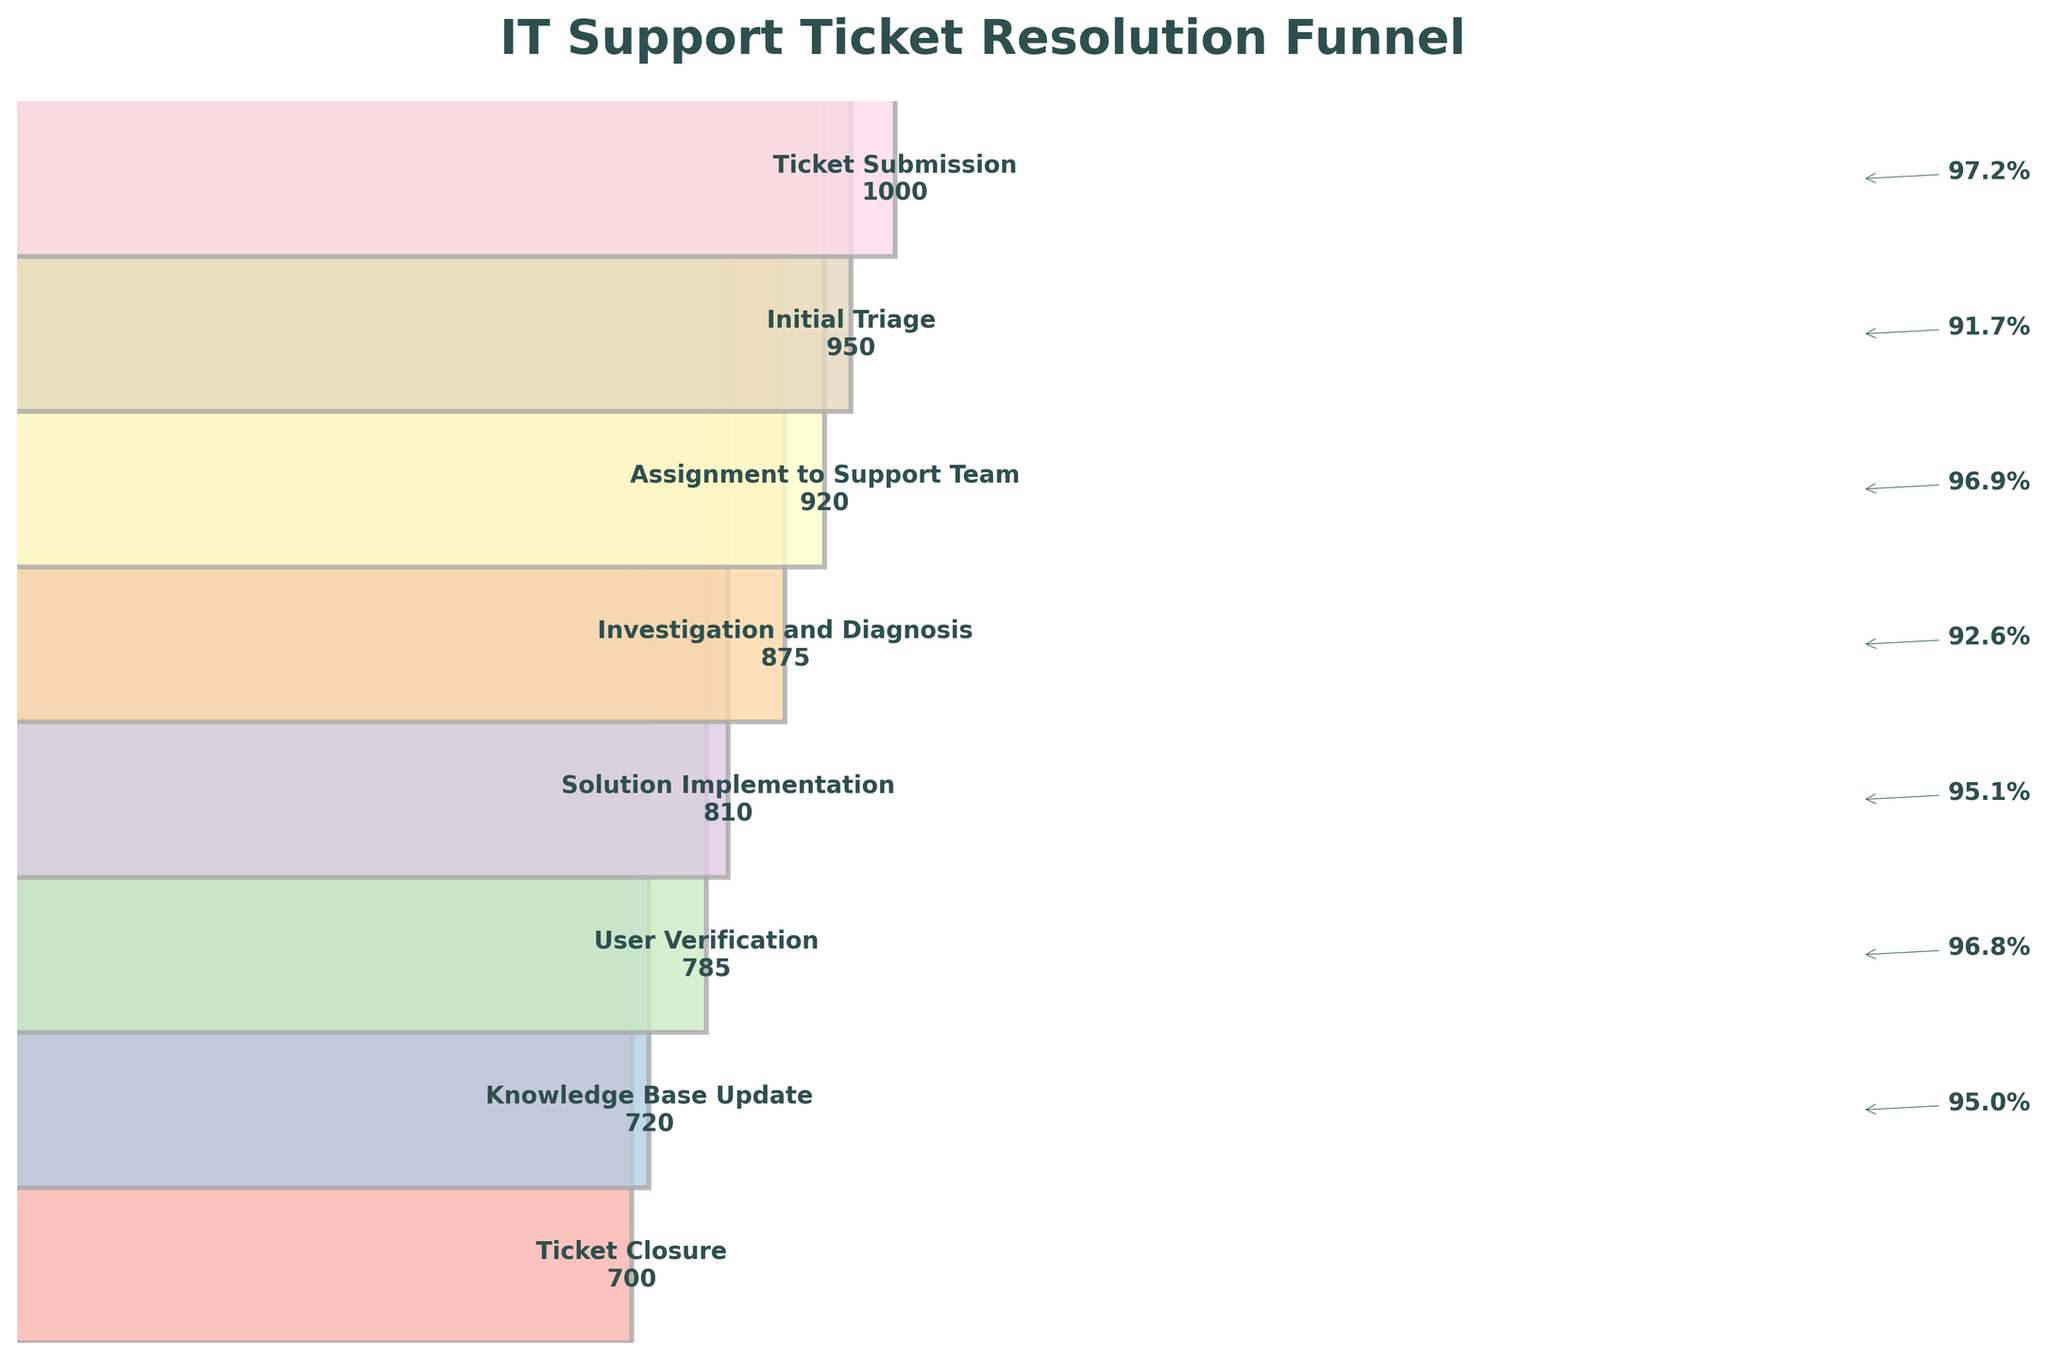What's the title of the figure? The title is located at the top of the figure in bold and large font to give a clear summary of what the chart represents. The title reads "IT Support Ticket Resolution Funnel".
Answer: IT Support Ticket Resolution Funnel How many support tickets make it to the 'Investigation and Diagnosis' step? The number of tickets at each step is labeled on the corresponding bars in the funnel chart. The 'Investigation and Diagnosis' step has 875 tickets.
Answer: 875 Which step shows the largest drop in the number of tickets from the previous step? By observing the percentage annotations between each step, you can determine the largest drop. The largest drop is from 'Solution Implementation' to 'User Verification', where it drops from 810 to 785.
Answer: Solution Implementation to User Verification What is the percentage of tickets that go from 'Ticket Submission' to 'Initial Triage'? The funnel chart shows numeric tickets at each step. The percentage can be calculated as (950 / 1000) * 100 which gives 95%.
Answer: 95% Compare the number of tickets at 'Assignment to Support Team' and 'Ticket Closure'. How many tickets are there in each step, and how many tickets were closed successfully? From the chart, 'Assignment to Support Team' has 920 tickets, and 'Ticket Closure' has 700 tickets. Therefore, 700 tickets are successfully closed.
Answer: Assignment to Support Team: 920, Ticket Closure: 700, 700 tickets closed successfully What is the difference in the number of tickets between 'Initial Triage' and 'Knowledge Base Update'? By looking at both steps, 'Initial Triage' has 950 tickets and 'Knowledge Base Update' has 720 tickets. The difference is 950 - 720, which is 230 tickets.
Answer: 230 Which specific step contributes to formalizing the knowledge for future reference? The step where formalizing knowledge for future reference happens is clearly labeled 'Knowledge Base Update'.
Answer: Knowledge Base Update Is the number of tickets at 'User Verification' more than at 'Solution Implementation'? Referring to the quantities on the funnel chart, 'User Verification' has 785 tickets compared to 'Solution Implementation' which has 810 tickets. Thus, 'User Verification' has fewer tickets.
Answer: No How many steps are there in the IT support ticket resolution process depicted in the funnel chart? Counting the labels on the funnel chart from 'Ticket Submission' to 'Ticket Closure' shows that there are 8 steps in the process.
Answer: 8 